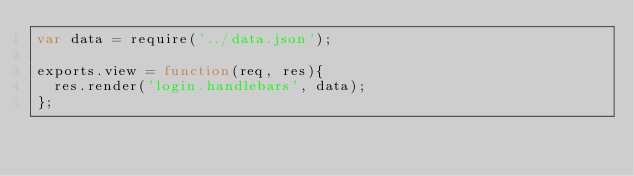<code> <loc_0><loc_0><loc_500><loc_500><_JavaScript_>var data = require('../data.json');

exports.view = function(req, res){
  res.render('login.handlebars', data);
};

</code> 